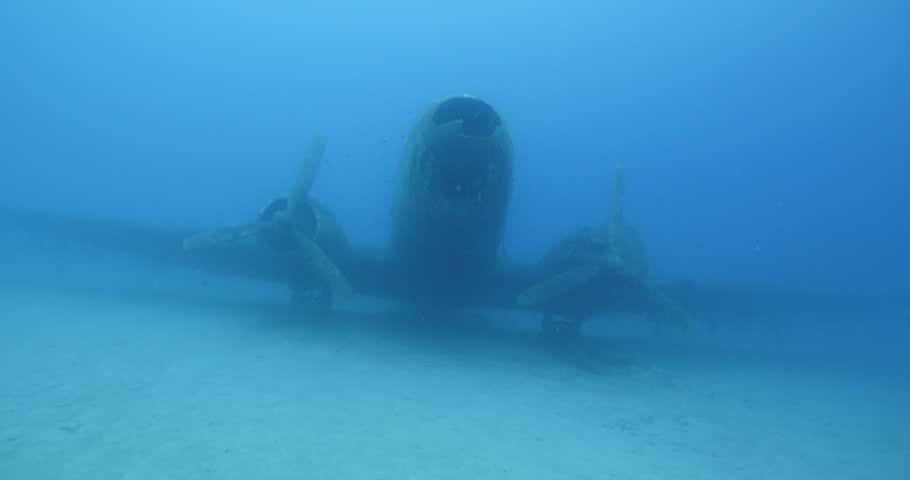What marine life could we expect to find around this underwater wreck? Surrounding this type of underwater wreckage, you might typically find a variety of fish species taking refuge in the structure, along with potential sightings of sea turtles, eels, and an assortment of coral beginning to form. 